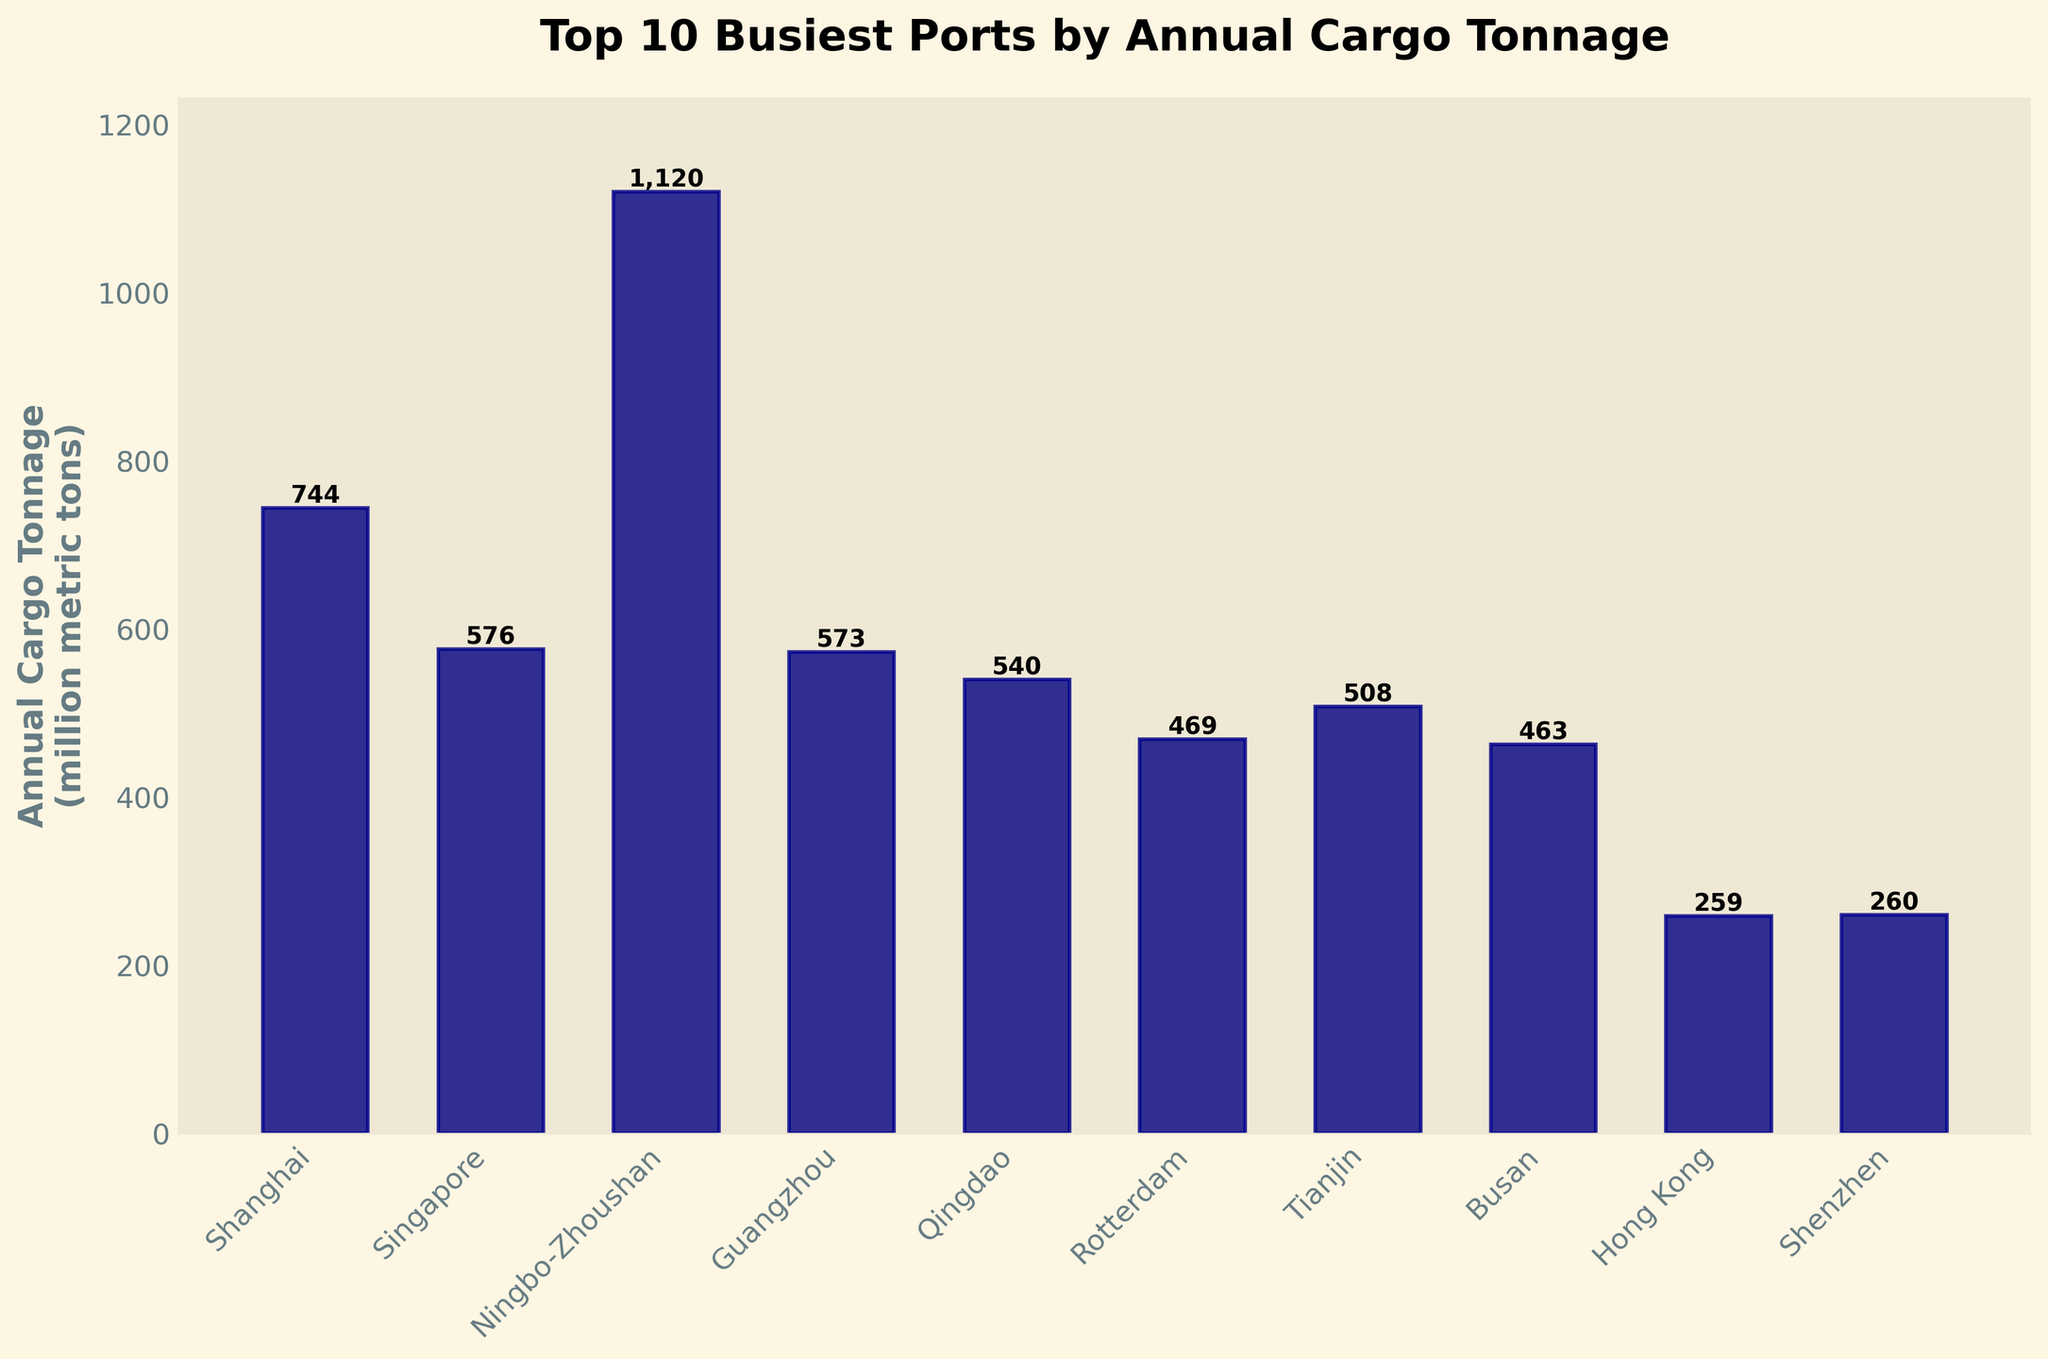What is the tallest bar in the chart? The tallest bar represents the port with the highest annual cargo tonnage. Looking at the heights of the bars, the tallest one belongs to Ningbo-Zhoushan with 1120 million metric tons.
Answer: Ningbo-Zhoushan Which port has a higher annual cargo tonnage, Shanghai or Guangzhou? To compare the annual cargo tonnage of the two ports, look at their respective bars. Shanghai has 744 million metric tons, while Guangzhou has 573 million metric tons. Therefore, Shanghai has a higher tonnage.
Answer: Shanghai What is the combined annual cargo tonnage of the top 3 busiest ports? The top 3 ports are Ningbo-Zhoushan (1120), Shanghai (744), and Singapore (576). Adding their tonnages together: 1120 + 744 + 576 = 2440 million metric tons.
Answer: 2440 million metric tons Which port has a lower annual cargo tonnage, Busan or Rotterdam? By comparing the heights of their bars, Rotterdam has 469 million metric tons and Busan has 463 million metric tons, making Busan the port with a lower annual cargo tonnage.
Answer: Busan Is the annual cargo tonnage of Singapore more than the sum of Hong Kong and Shenzhen? Singapore's bar shows 576 million metric tons. Hong Kong has 259 and Shenzhen has 260. Adding Hong Kong and Shenzhen: 259 + 260 = 519. Since 576 > 519, Singapore's tonnage is indeed more.
Answer: Yes Which is the only port with an annual cargo tonnage above 1000 million metric tons? Only one bar extends above 1000 million metric tons. This bar corresponds to Ningbo-Zhoushan with 1120 million metric tons.
Answer: Ningbo-Zhoushan What is the visual difference in height between the bars for Tianjin and Qingdao? Tianjin has 508 million metric tons, and Qingdao has 540 million metric tons. Qingdao's bar is slightly higher than Tianjin's by a difference of 32 million metric tons.
Answer: 32 million metric tons What is the average annual cargo tonnage for all ports shown? First, sum the tonnages: 1120 (Ningbo-Zhoushan) + 744 (Shanghai) + 576 (Singapore) + 573 (Guangzhou) + 540 (Qingdao) + 469 (Rotterdam) + 508 (Tianjin) + 463 (Busan) + 259 (Hong Kong) + 260 (Shenzhen) = 5512. The average is 5512 / 10 = 551.2 million metric tons.
Answer: 551.2 million metric tons Which ports have annual cargo tonnages closest to 500 million metric tons? Ports close to 500 million metric tons by examining the bar lengths are Qingdao with 540 and Tianjin with 508 million metric tons.
Answer: Qingdao and Tianjin How much higher is Shanghai's annual cargo tonnage compared to Busan's? Shanghai has 744 million metric tons, and Busan has 463 million metric tons. The difference in height is 744 - 463 = 281 million metric tons.
Answer: 281 million metric tons 